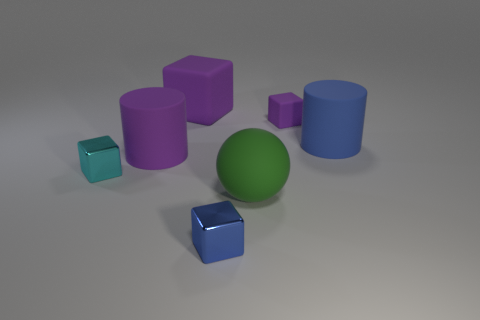There is a big rubber cylinder in front of the big cylinder that is to the right of the tiny purple thing; is there a big purple object that is right of it?
Keep it short and to the point. Yes. What shape is the green rubber object that is the same size as the blue rubber thing?
Offer a very short reply. Sphere. Are there any cylinders of the same color as the big block?
Offer a terse response. Yes. Is the tiny purple rubber thing the same shape as the large blue thing?
Give a very brief answer. No. How many small objects are either blue cubes or cyan shiny things?
Give a very brief answer. 2. What color is the big ball that is the same material as the small purple block?
Provide a succinct answer. Green. How many big cylinders are the same material as the big purple cube?
Offer a very short reply. 2. Is the size of the purple block on the right side of the big rubber block the same as the cylinder in front of the big blue cylinder?
Your answer should be very brief. No. What is the material of the purple object to the left of the big object behind the blue cylinder?
Provide a succinct answer. Rubber. Is the number of small cyan cubes behind the cyan shiny block less than the number of small matte things behind the big green ball?
Provide a short and direct response. Yes. 